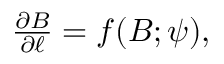<formula> <loc_0><loc_0><loc_500><loc_500>\begin{array} { r } { \frac { \partial B } { \partial \ell } = f ( B ; \psi ) , } \end{array}</formula> 